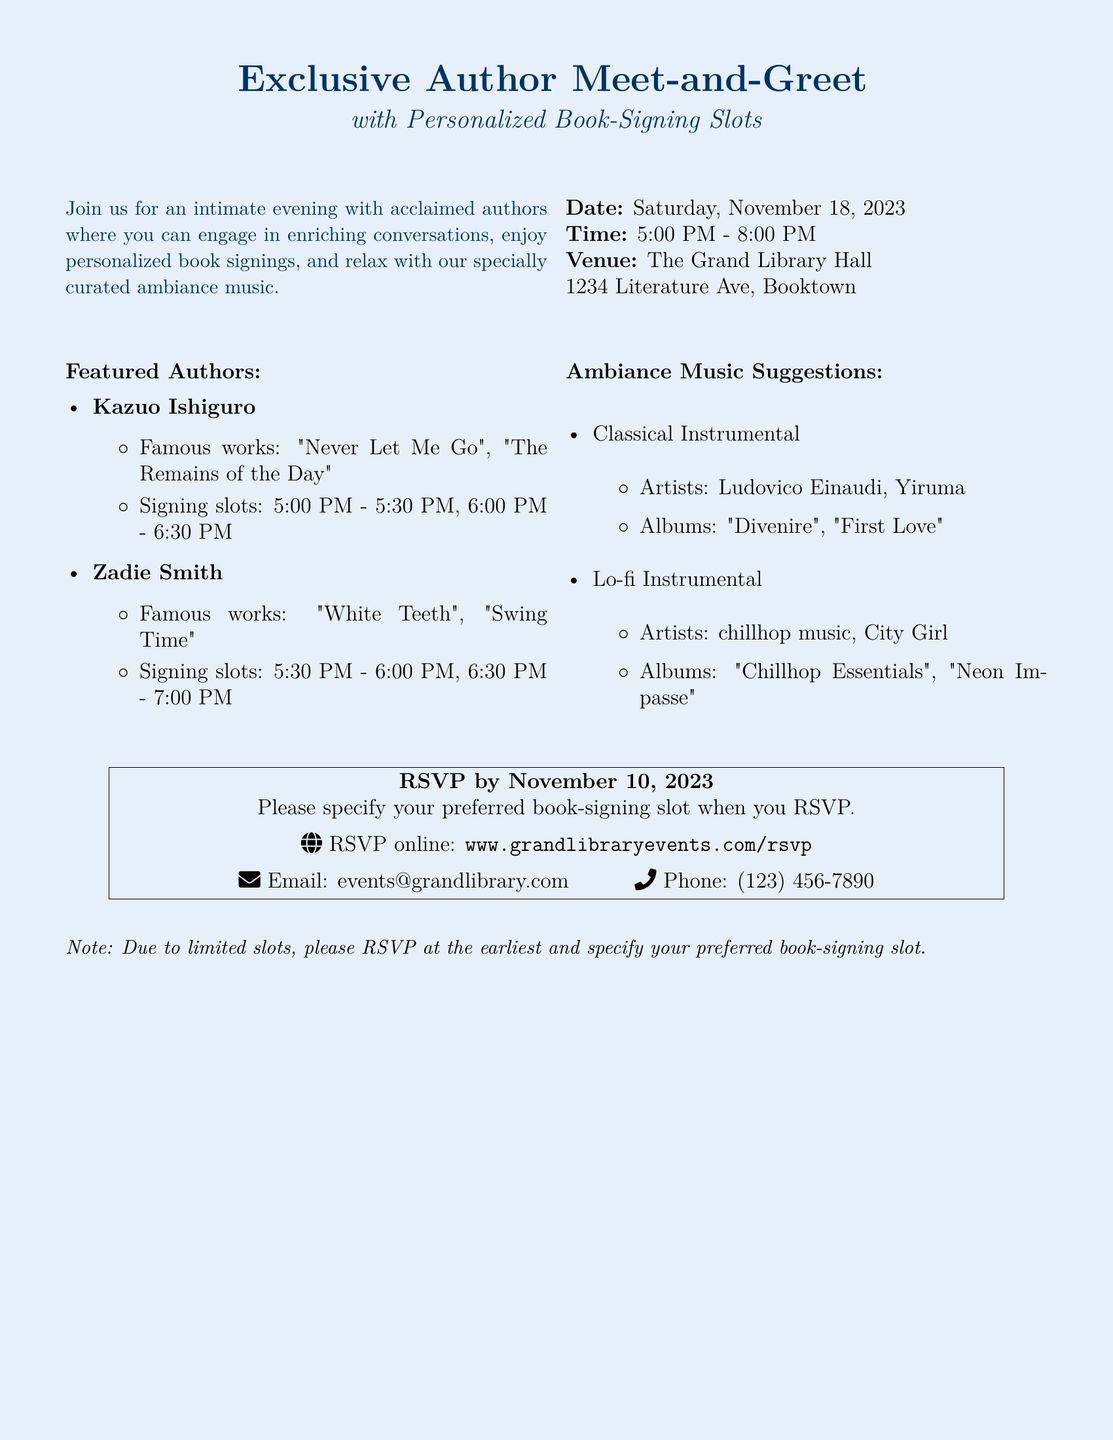What is the date of the event? The date of the event is mentioned prominently in the document.
Answer: Saturday, November 18, 2023 What time does the event start? The starting time of the event is provided in the time section of the document.
Answer: 5:00 PM How many signing slots does Kazuo Ishiguro have? The document lists the signing slots available for each author.
Answer: Two What is the venue of the event? The venue is specified in the location section of the RSVP card.
Answer: The Grand Library Hall Who are the featured authors? The document specifically lists the authors who will be present at the event.
Answer: Kazuo Ishiguro, Zadie Smith What type of music is suggested for the ambiance? The document includes a section on ambiance music suggestions, indicating the genre.
Answer: Classical Instrumental, Lo-fi Instrumental When is the RSVP deadline? The RSVP deadline is explicitly stated in the RSVP section of the document.
Answer: November 10, 2023 What should be specified when RSVPing? The RSVP card mentions a requirement for attendees when confirming their attendance.
Answer: Preferred book-signing slot How can I RSVP online? The document provides specific online information for RSVP.
Answer: www.grandlibraryevents.com/rsvp 